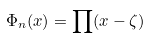<formula> <loc_0><loc_0><loc_500><loc_500>\Phi _ { n } ( x ) = \prod ( x - \zeta )</formula> 